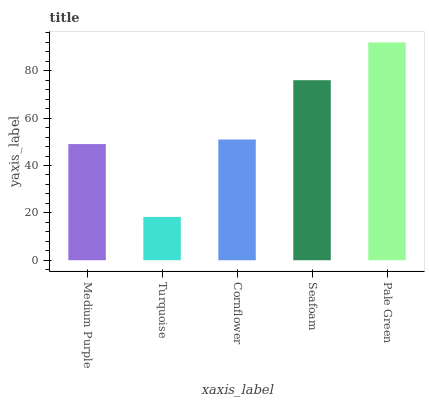Is Turquoise the minimum?
Answer yes or no. Yes. Is Pale Green the maximum?
Answer yes or no. Yes. Is Cornflower the minimum?
Answer yes or no. No. Is Cornflower the maximum?
Answer yes or no. No. Is Cornflower greater than Turquoise?
Answer yes or no. Yes. Is Turquoise less than Cornflower?
Answer yes or no. Yes. Is Turquoise greater than Cornflower?
Answer yes or no. No. Is Cornflower less than Turquoise?
Answer yes or no. No. Is Cornflower the high median?
Answer yes or no. Yes. Is Cornflower the low median?
Answer yes or no. Yes. Is Turquoise the high median?
Answer yes or no. No. Is Seafoam the low median?
Answer yes or no. No. 